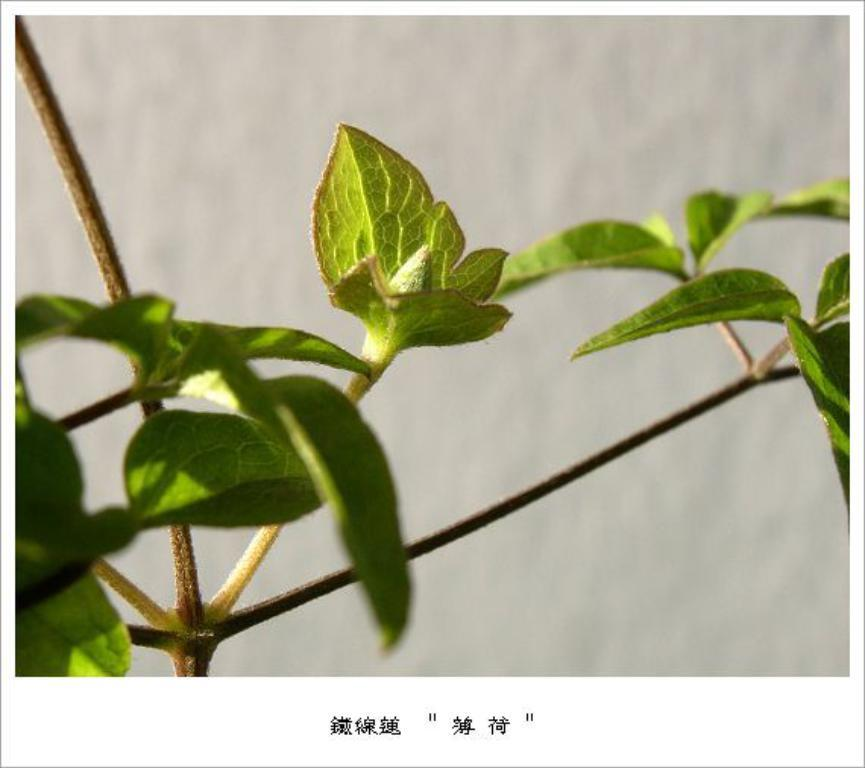What is the main subject of the image? The main subject of the image is a plant. How has the image been altered? The image is an edited image of a plant. What can be observed about the background of the image? The background of the image is blurred. Who is the owner of the basketball team in the image? There is no basketball team or owner present in the image; it features an edited image of a plant with a blurred background. 